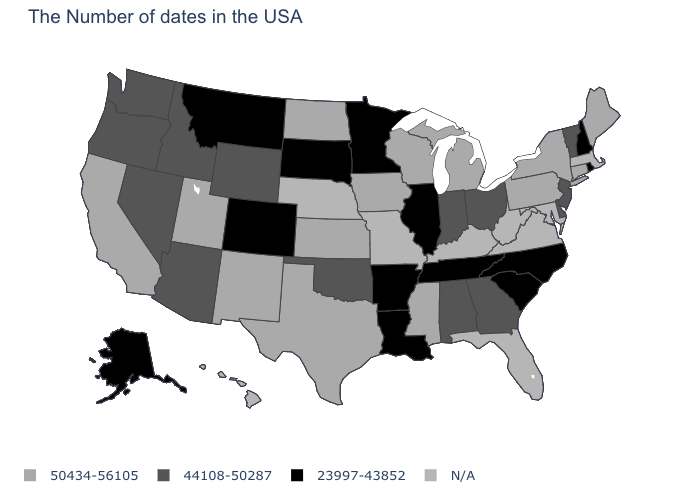Name the states that have a value in the range 50434-56105?
Give a very brief answer. Maine, Connecticut, New York, Pennsylvania, Michigan, Wisconsin, Mississippi, Iowa, Kansas, Texas, North Dakota, New Mexico, Utah, California. Is the legend a continuous bar?
Give a very brief answer. No. What is the value of New York?
Write a very short answer. 50434-56105. What is the value of Hawaii?
Keep it brief. N/A. What is the highest value in the USA?
Write a very short answer. 50434-56105. What is the value of Idaho?
Concise answer only. 44108-50287. What is the highest value in the USA?
Concise answer only. 50434-56105. What is the lowest value in states that border Washington?
Be succinct. 44108-50287. Name the states that have a value in the range 50434-56105?
Be succinct. Maine, Connecticut, New York, Pennsylvania, Michigan, Wisconsin, Mississippi, Iowa, Kansas, Texas, North Dakota, New Mexico, Utah, California. What is the lowest value in the USA?
Quick response, please. 23997-43852. Does Ohio have the lowest value in the USA?
Concise answer only. No. Does the first symbol in the legend represent the smallest category?
Concise answer only. No. Name the states that have a value in the range 44108-50287?
Answer briefly. Vermont, New Jersey, Delaware, Ohio, Georgia, Indiana, Alabama, Oklahoma, Wyoming, Arizona, Idaho, Nevada, Washington, Oregon. Name the states that have a value in the range 44108-50287?
Write a very short answer. Vermont, New Jersey, Delaware, Ohio, Georgia, Indiana, Alabama, Oklahoma, Wyoming, Arizona, Idaho, Nevada, Washington, Oregon. What is the value of Montana?
Short answer required. 23997-43852. 